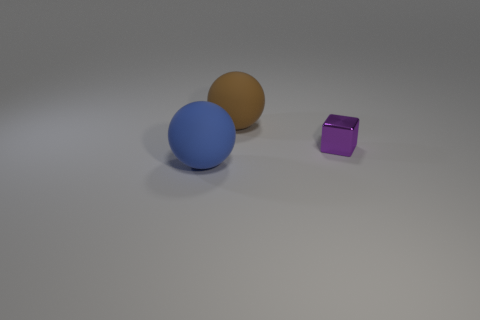There is a purple thing in front of the brown matte ball; is its size the same as the big brown ball?
Keep it short and to the point. No. How big is the matte object on the left side of the ball that is behind the tiny object?
Give a very brief answer. Large. Are the blue ball and the big object that is on the right side of the blue matte ball made of the same material?
Provide a short and direct response. Yes. Is the number of small objects that are left of the big blue rubber thing less than the number of big brown objects that are in front of the tiny purple block?
Your answer should be compact. No. The object that is the same material as the blue sphere is what color?
Your answer should be very brief. Brown. There is a large object that is behind the small object; is there a shiny thing behind it?
Ensure brevity in your answer.  No. What color is the other matte sphere that is the same size as the brown matte sphere?
Ensure brevity in your answer.  Blue. What number of objects are small green metal things or brown balls?
Keep it short and to the point. 1. How big is the purple shiny cube on the right side of the big object that is in front of the large rubber object that is behind the tiny shiny object?
Keep it short and to the point. Small. What number of large objects have the same material as the small cube?
Make the answer very short. 0. 